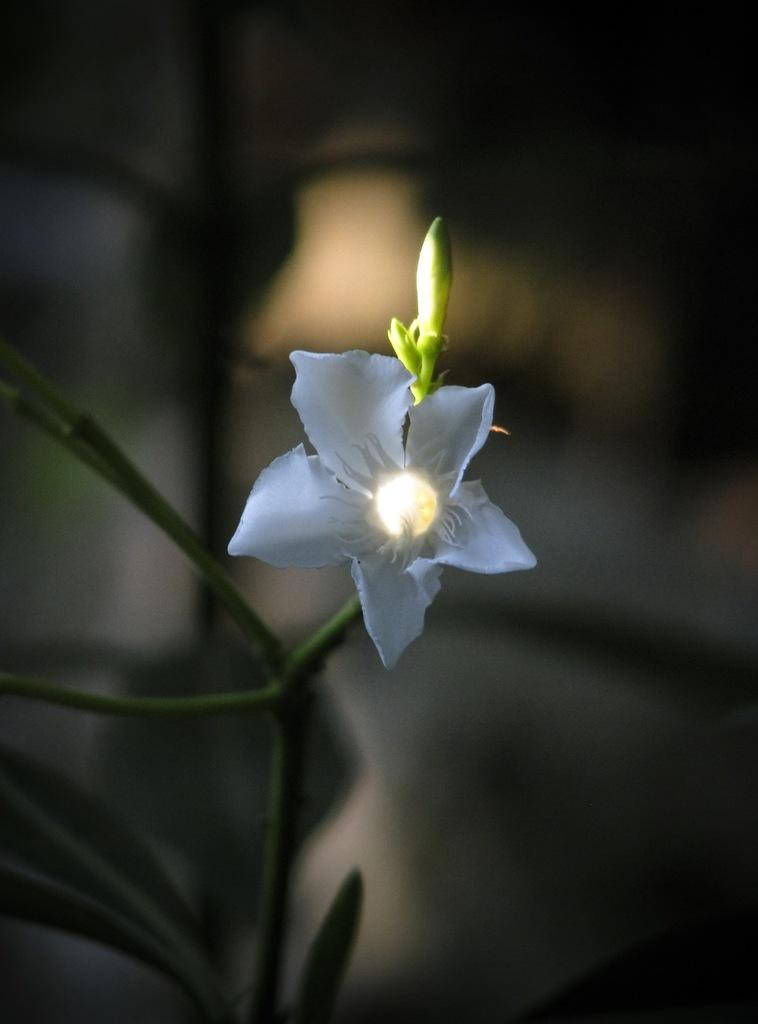What type of flower is present in the image? There is a white color flower in the image. What stage of growth are the flowers on the plant in the image? There are buds on the plant in the image. Can you describe the background of the image? The background of the image is blurred. What type of zephyr is mentioned in the title of the image? There is no title mentioned in the image, and therefore no zephyr is associated with it. 